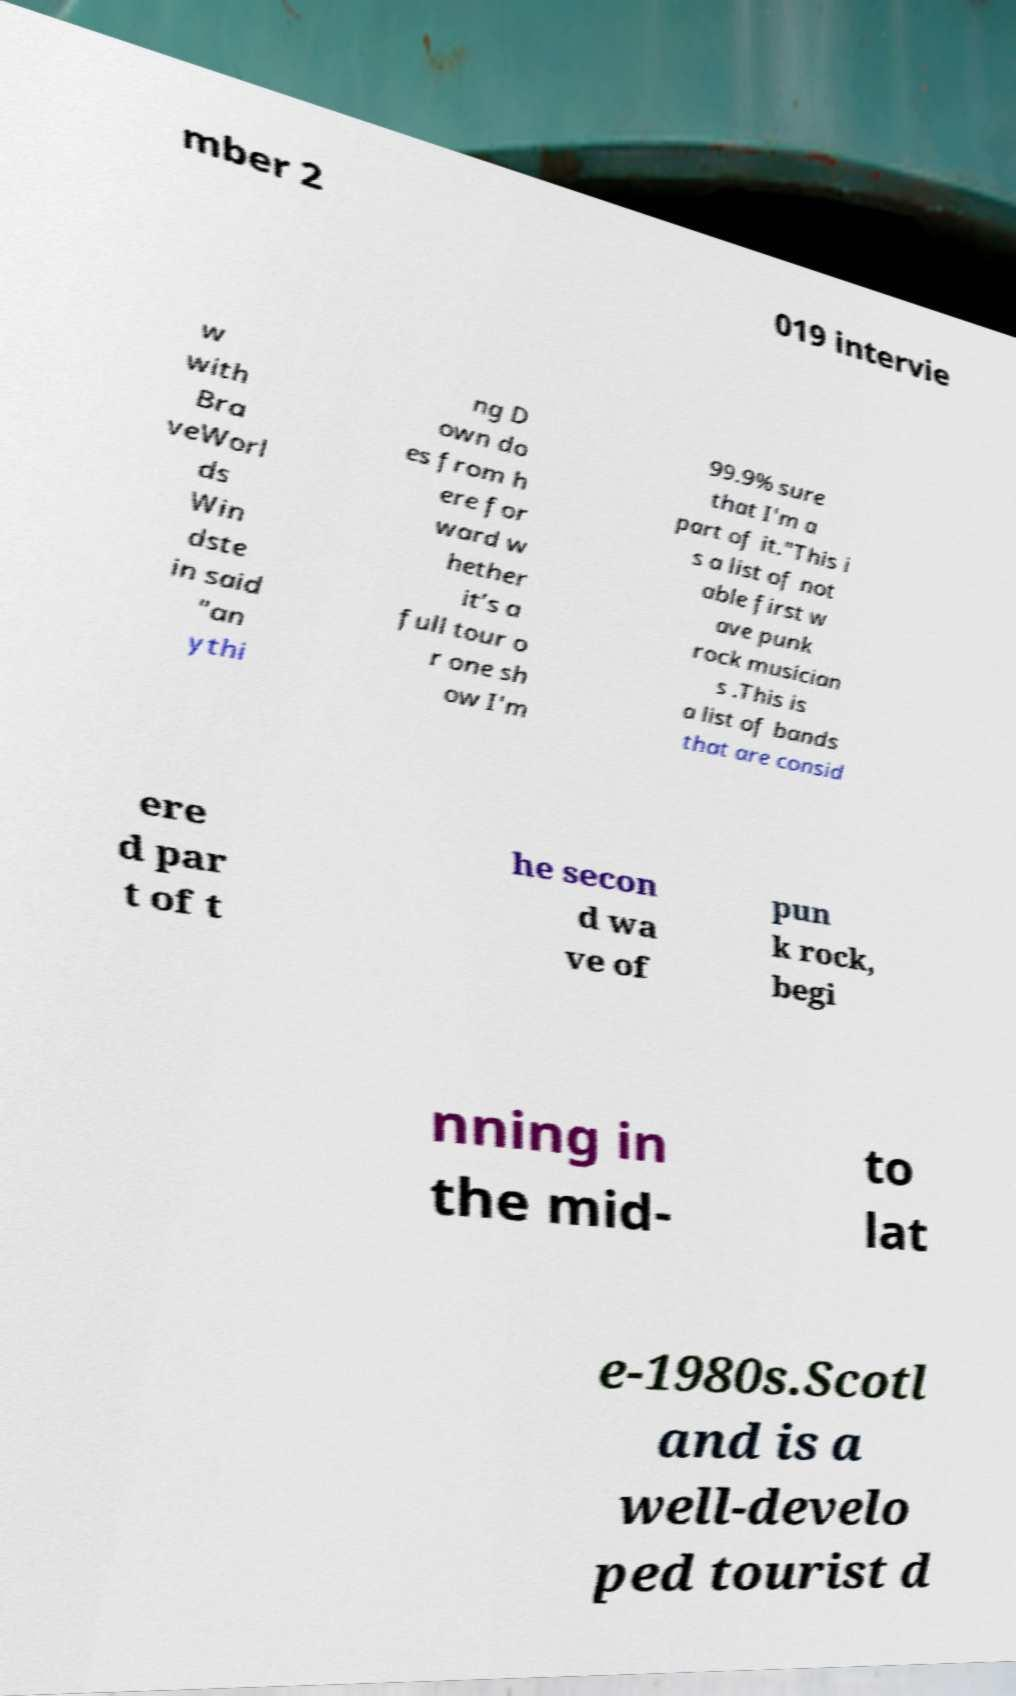Please read and relay the text visible in this image. What does it say? mber 2 019 intervie w with Bra veWorl ds Win dste in said "an ythi ng D own do es from h ere for ward w hether it’s a full tour o r one sh ow I'm 99.9% sure that I'm a part of it."This i s a list of not able first w ave punk rock musician s .This is a list of bands that are consid ere d par t of t he secon d wa ve of pun k rock, begi nning in the mid- to lat e-1980s.Scotl and is a well-develo ped tourist d 